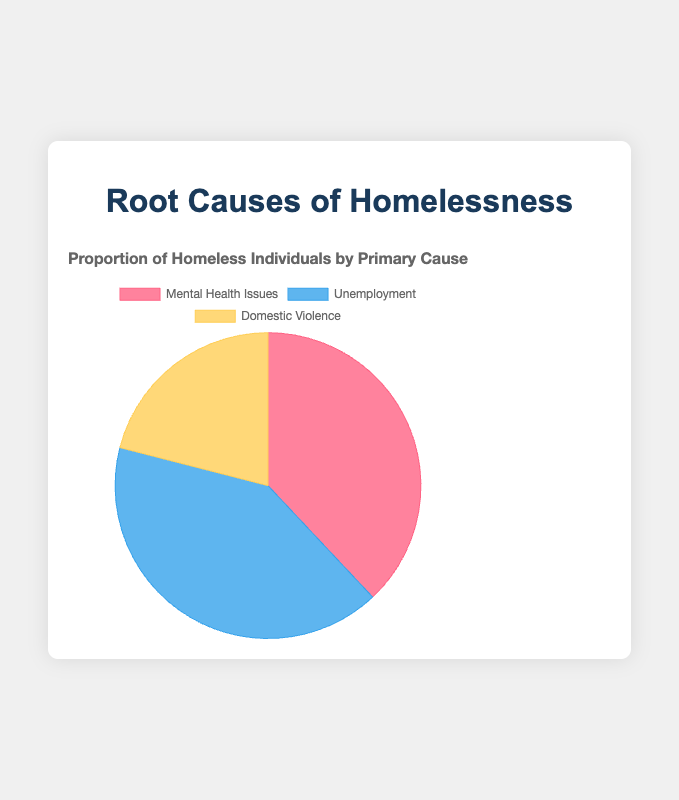What is the primary cause with the highest proportion of homeless individuals? To find the answer, look at the proportions represented in the pie chart and identify the highest value. Here, Unemployment has the highest proportion at 41%.
Answer: Unemployment Which primary cause has the smallest representation? Examine the pie chart for the smallest proportion value among the causes. Domestic Violence has the smallest representation at 21%.
Answer: Domestic Violence What is the combined proportion of homeless individuals due to Mental Health Issues and Domestic Violence? Add the proportion values for Mental Health Issues (38%) and Domestic Violence (21%). The combined proportion is 38% + 21% = 59%.
Answer: 59% How much greater is the proportion of homelessness caused by Unemployment compared to Mental Health Issues? Subtract the proportion of Mental Health Issues (38%) from the proportion of Unemployment (41%). The difference is 41% - 38% = 3%.
Answer: 3% What is the average proportion of homeless individuals represented by the three causes? Sum the proportions of the three causes: 38% + 41% + 21% = 100%. Then, divide by the number of causes, which is 3. The average is 100% / 3 ≈ 33.33%.
Answer: 33.33% Which two causes have the closest proportions? Compare the differences between each pair of causes: Mental Health Issues (38%) and Unemployment (41%) have the closest proportions with a difference of 3%.
Answer: Mental Health Issues and Unemployment What is the visual color representation for the proportion of homelessness due to Domestic Violence? Refer to the color coding in the pie chart, where Domestic Violence is represented by a yellow section.
Answer: Yellow Is the proportion of Mental Health Issues greater than half of the total proportion in the chart? Mental Health Issues account for 38%, which is less than 50%. Hence, the answer is no.
Answer: No Which section occupies the middle value in terms of its proportional representation? With the proportions being 38%, 41%, and 21%, the middle value is 38%, corresponding to Mental Health Issues.
Answer: Mental Health Issues What is the combined proportion of causes other than Unemployment? Add the proportions of Mental Health Issues (38%) and Domestic Violence (21%). The combined proportion is 38% + 21% = 59%.
Answer: 59% 